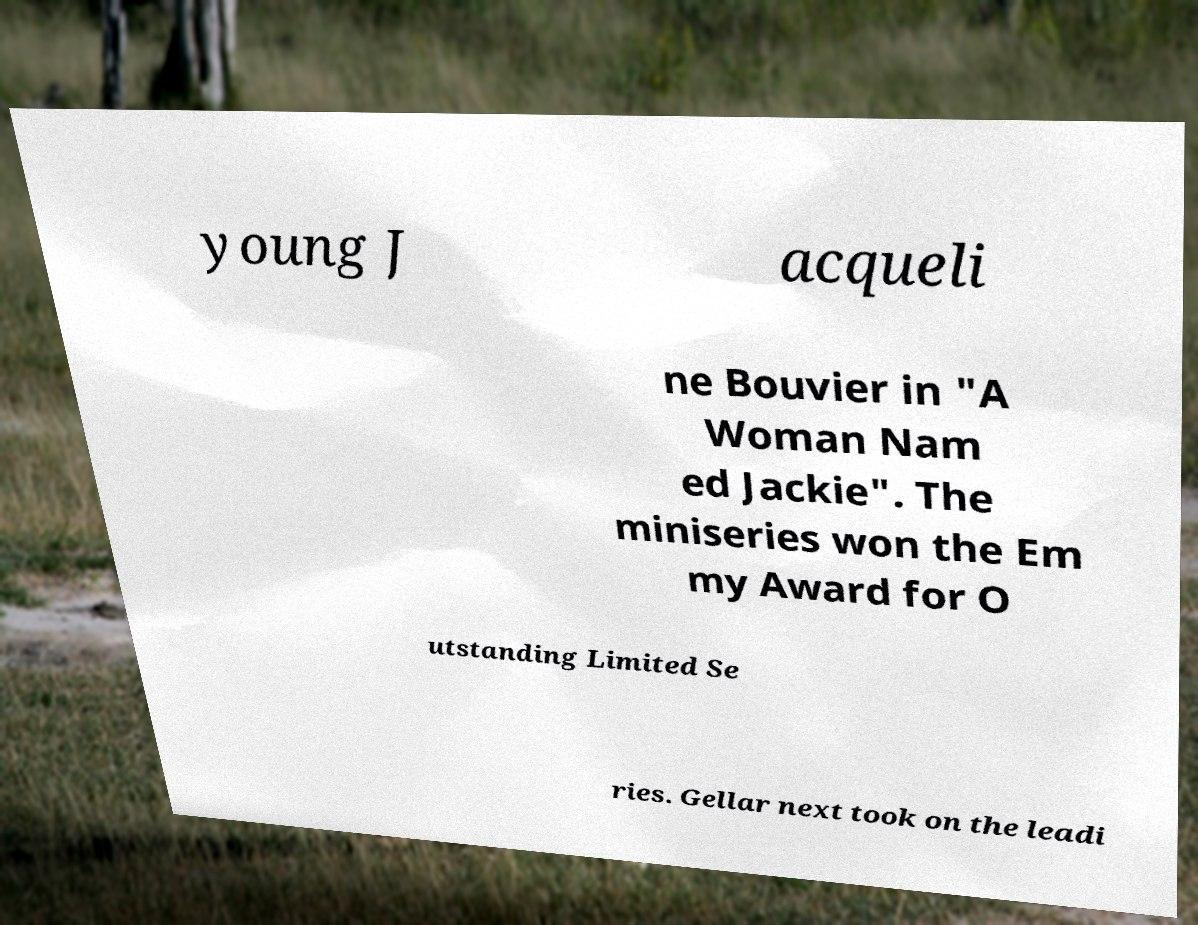For documentation purposes, I need the text within this image transcribed. Could you provide that? young J acqueli ne Bouvier in "A Woman Nam ed Jackie". The miniseries won the Em my Award for O utstanding Limited Se ries. Gellar next took on the leadi 